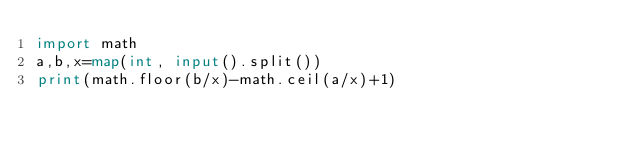Convert code to text. <code><loc_0><loc_0><loc_500><loc_500><_Python_>import math
a,b,x=map(int, input().split())
print(math.floor(b/x)-math.ceil(a/x)+1)</code> 